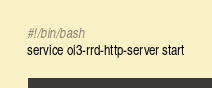<code> <loc_0><loc_0><loc_500><loc_500><_Bash_>#!/bin/bash
service oi3-rrd-http-server start
</code> 